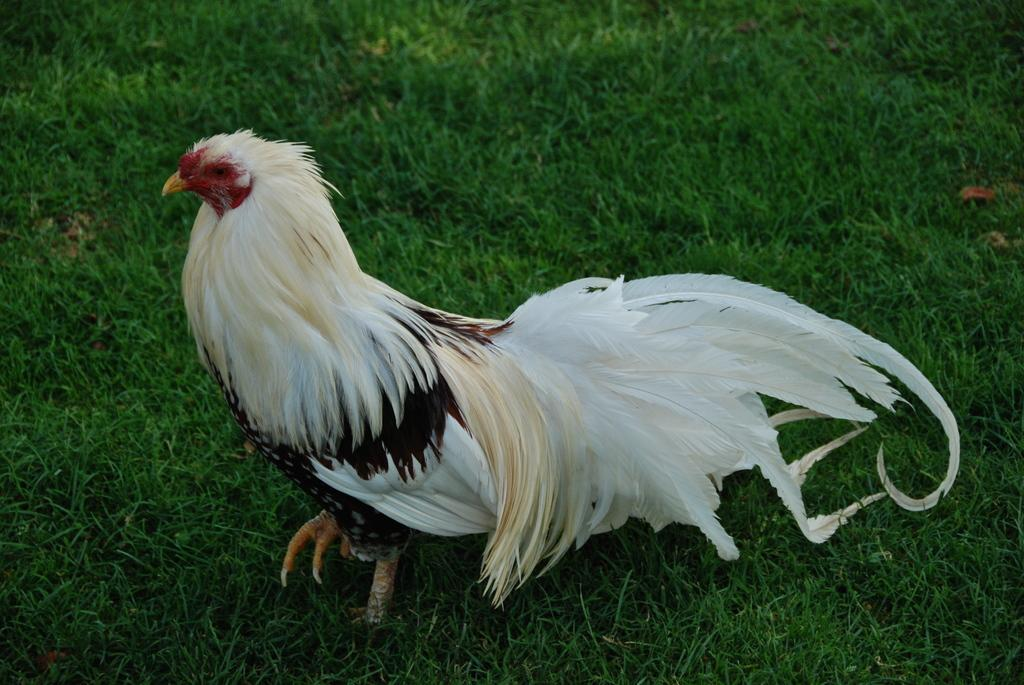What type of animal can be seen in the image? There is a bird in the image. Where is the bird located? The bird is on the grass. What type of sofa can be seen in the image? There is no sofa present in the image; it features a bird on the grass. What kind of beast is interacting with the bird in the image? There is no beast present in the image; only the bird is visible. 